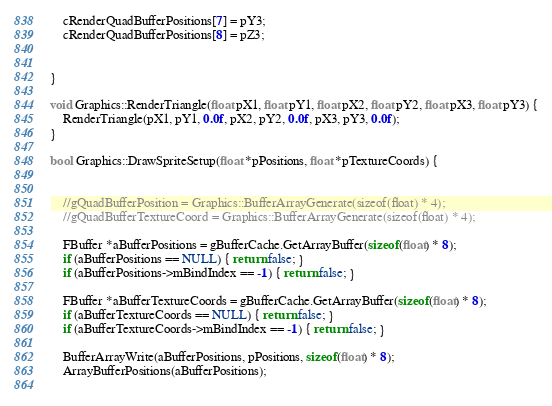<code> <loc_0><loc_0><loc_500><loc_500><_C++_>    cRenderQuadBufferPositions[7] = pY3;
    cRenderQuadBufferPositions[8] = pZ3;
    
    
}

void Graphics::RenderTriangle(float pX1, float pY1, float pX2, float pY2, float pX3, float pY3) {
    RenderTriangle(pX1, pY1, 0.0f, pX2, pY2, 0.0f, pX3, pY3, 0.0f);
}

bool Graphics::DrawSpriteSetup(float *pPositions, float *pTextureCoords) {
    
    
    //gQuadBufferPosition = Graphics::BufferArrayGenerate(sizeof(float) * 4);
    //gQuadBufferTextureCoord = Graphics::BufferArrayGenerate(sizeof(float) * 4);
    
    FBuffer *aBufferPositions = gBufferCache.GetArrayBuffer(sizeof(float) * 8);
    if (aBufferPositions == NULL) { return false; }
    if (aBufferPositions->mBindIndex == -1) { return false; }
    
    FBuffer *aBufferTextureCoords = gBufferCache.GetArrayBuffer(sizeof(float) * 8);
    if (aBufferTextureCoords == NULL) { return false; }
    if (aBufferTextureCoords->mBindIndex == -1) { return false; }
    
    BufferArrayWrite(aBufferPositions, pPositions, sizeof(float) * 8);
    ArrayBufferPositions(aBufferPositions);
    </code> 